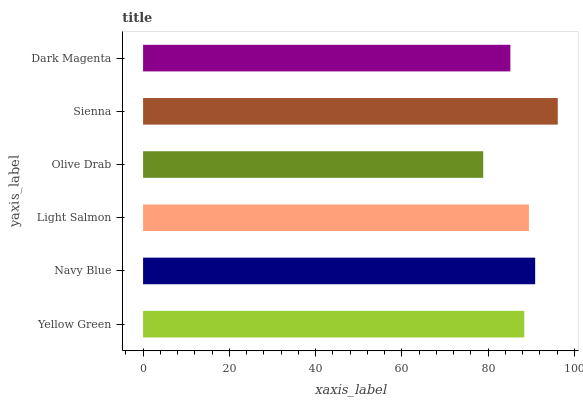Is Olive Drab the minimum?
Answer yes or no. Yes. Is Sienna the maximum?
Answer yes or no. Yes. Is Navy Blue the minimum?
Answer yes or no. No. Is Navy Blue the maximum?
Answer yes or no. No. Is Navy Blue greater than Yellow Green?
Answer yes or no. Yes. Is Yellow Green less than Navy Blue?
Answer yes or no. Yes. Is Yellow Green greater than Navy Blue?
Answer yes or no. No. Is Navy Blue less than Yellow Green?
Answer yes or no. No. Is Light Salmon the high median?
Answer yes or no. Yes. Is Yellow Green the low median?
Answer yes or no. Yes. Is Olive Drab the high median?
Answer yes or no. No. Is Sienna the low median?
Answer yes or no. No. 